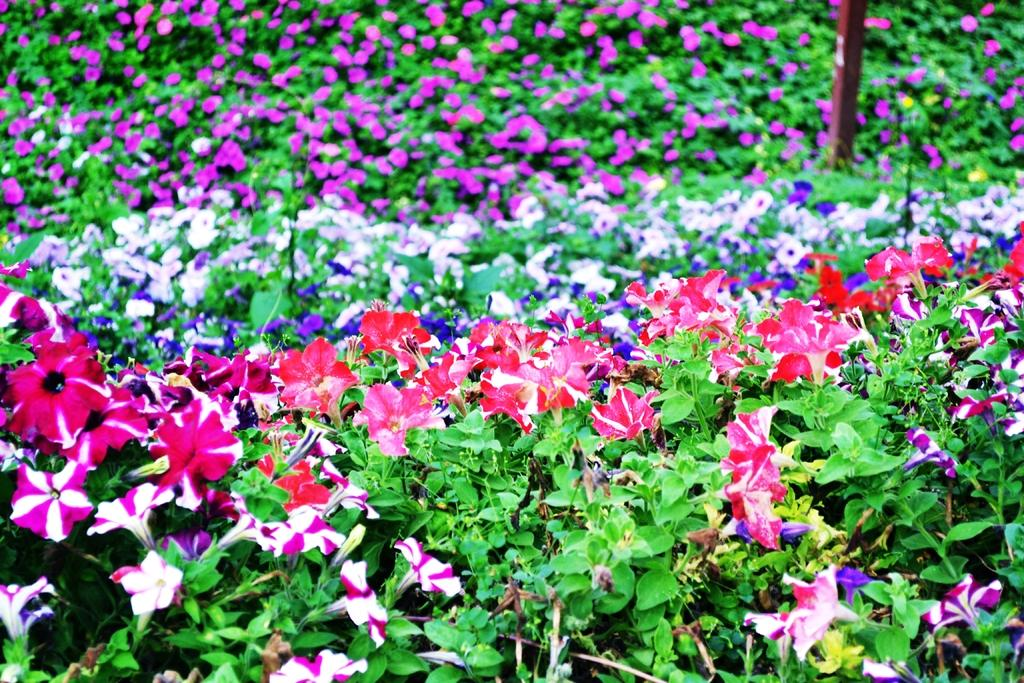What type of plants are at the bottom of the image? There are plants with flowers and green leaves at the bottom of the image. What can be seen in the background of the image? In the background, there is a pole and plants with flowers and leaves. What type of patch is visible on the pole in the image? There is no patch visible on the pole in the image. What industry is represented by the plants in the image? The image does not represent any specific industry; it simply shows plants with flowers and green leaves. 